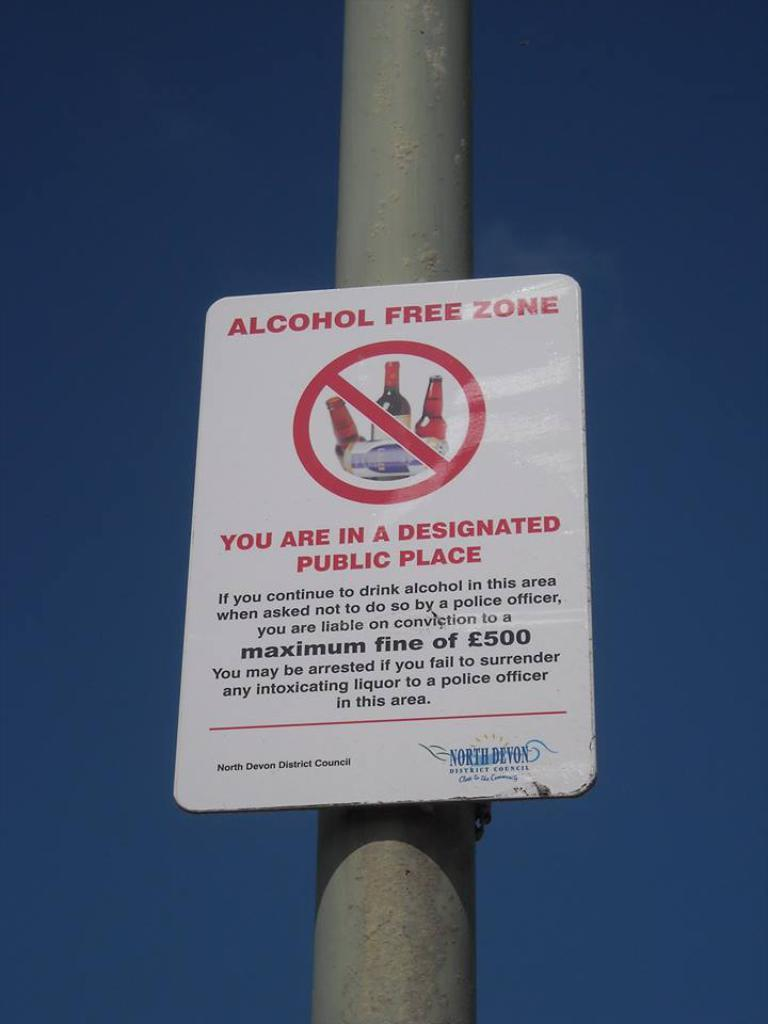<image>
Give a short and clear explanation of the subsequent image. A alcohol free zone sign on a pole outside 